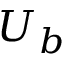<formula> <loc_0><loc_0><loc_500><loc_500>U _ { b }</formula> 